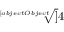Convert formula to latex. <formula><loc_0><loc_0><loc_500><loc_500>\sqrt { [ } [ o b j e c t O b j e c t ] ] { 4 }</formula> 